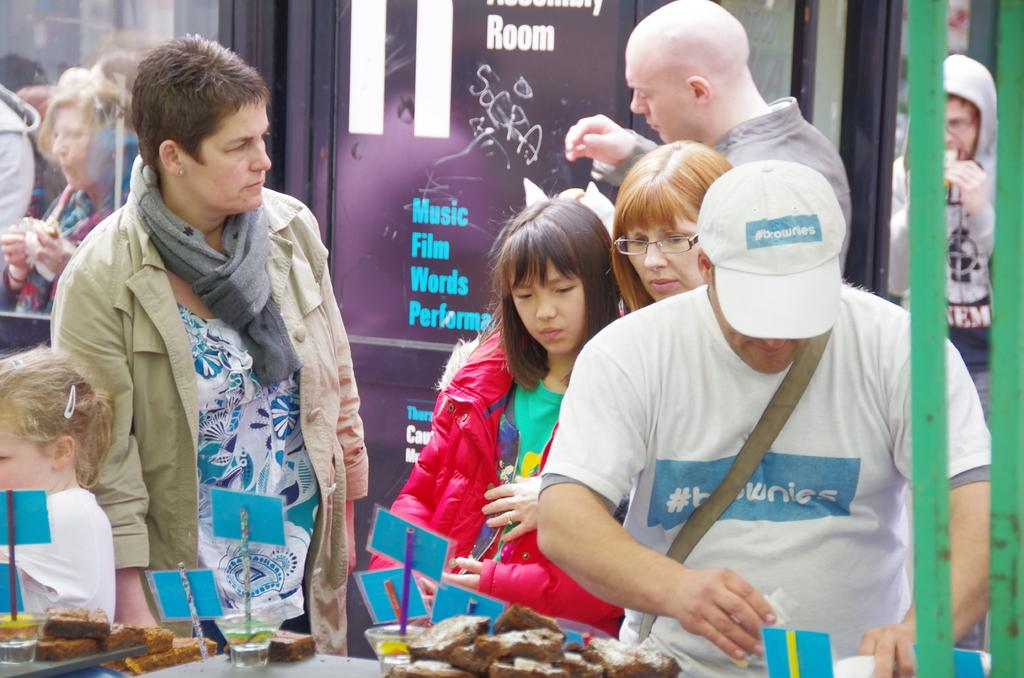How many people are in the image? There are people in the image, but the exact number is not specified. What are some of the people doing in the image? Some of the people are eating food in the image. What types of food items can be seen in the image? There are food items in the image, including those being eaten by the people. What objects are used to hold food in the image? There are bowls in the image that are used to hold food. What other items can be seen in the image besides food and bowls? There are cards and a poster with text in the image. What type of coastline can be seen in the image? There is no coastline present in the image. Is there a maid in the image? There is no mention of a maid in the image. 